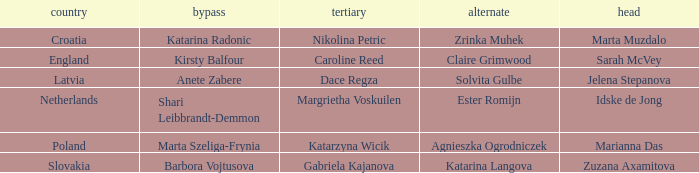Who is the Second with Nikolina Petric as Third? Zrinka Muhek. 